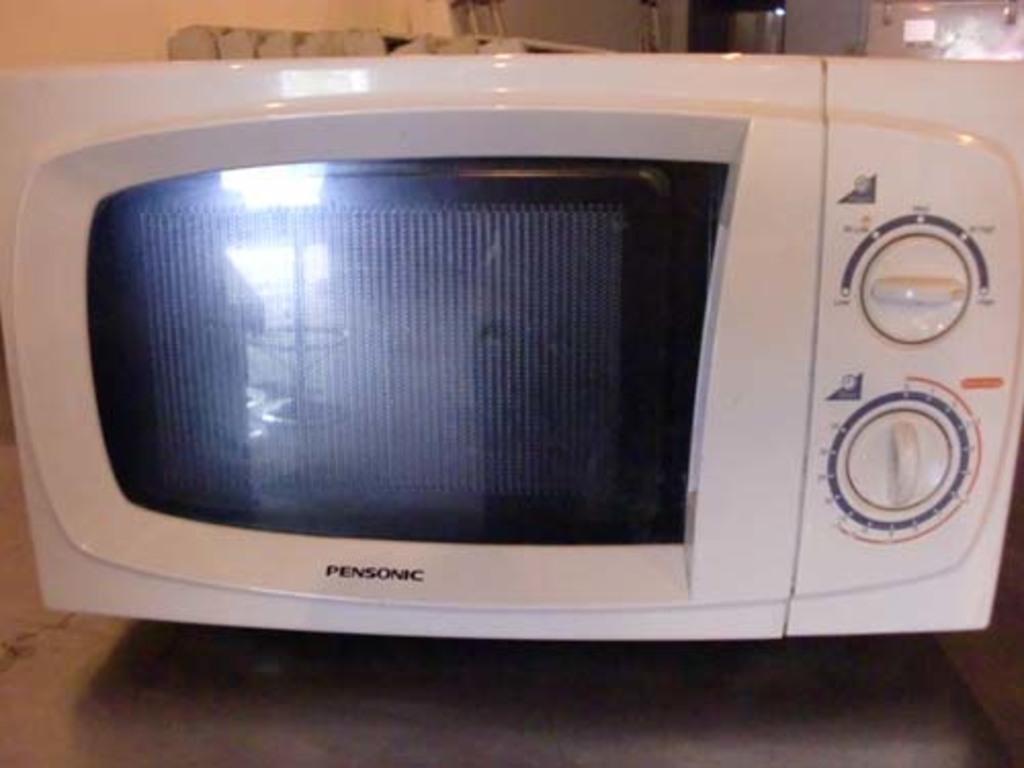Describe this image in one or two sentences. In this image there is a microwave oven having two knobs on it. Oven is kept on the table. 